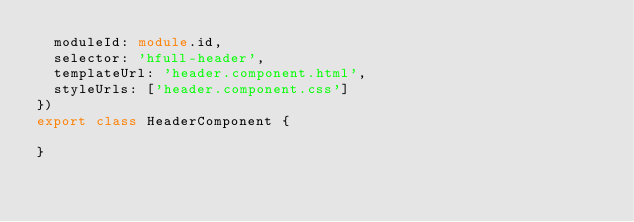Convert code to text. <code><loc_0><loc_0><loc_500><loc_500><_TypeScript_>  moduleId: module.id,
  selector: 'hfull-header',
  templateUrl: 'header.component.html',
  styleUrls: ['header.component.css']
})
export class HeaderComponent {

}
</code> 